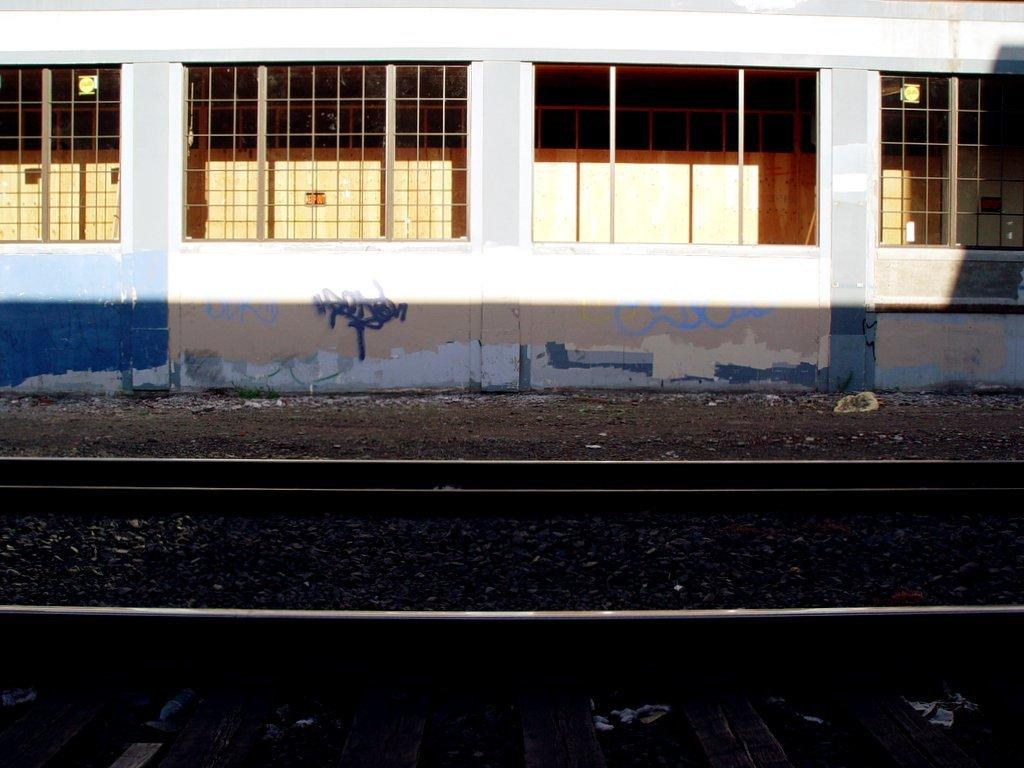Where was the image taken? The image was clicked outside. What can be seen in the foreground of the image? There are gravels and a railway track in the foreground of the image. What can be seen in the background of the image? There are windows and a wall of a building visible in the background of the image. What type of gold jewelry is the person wearing in the image? There is no person visible in the image, and therefore no jewelry can be observed. 